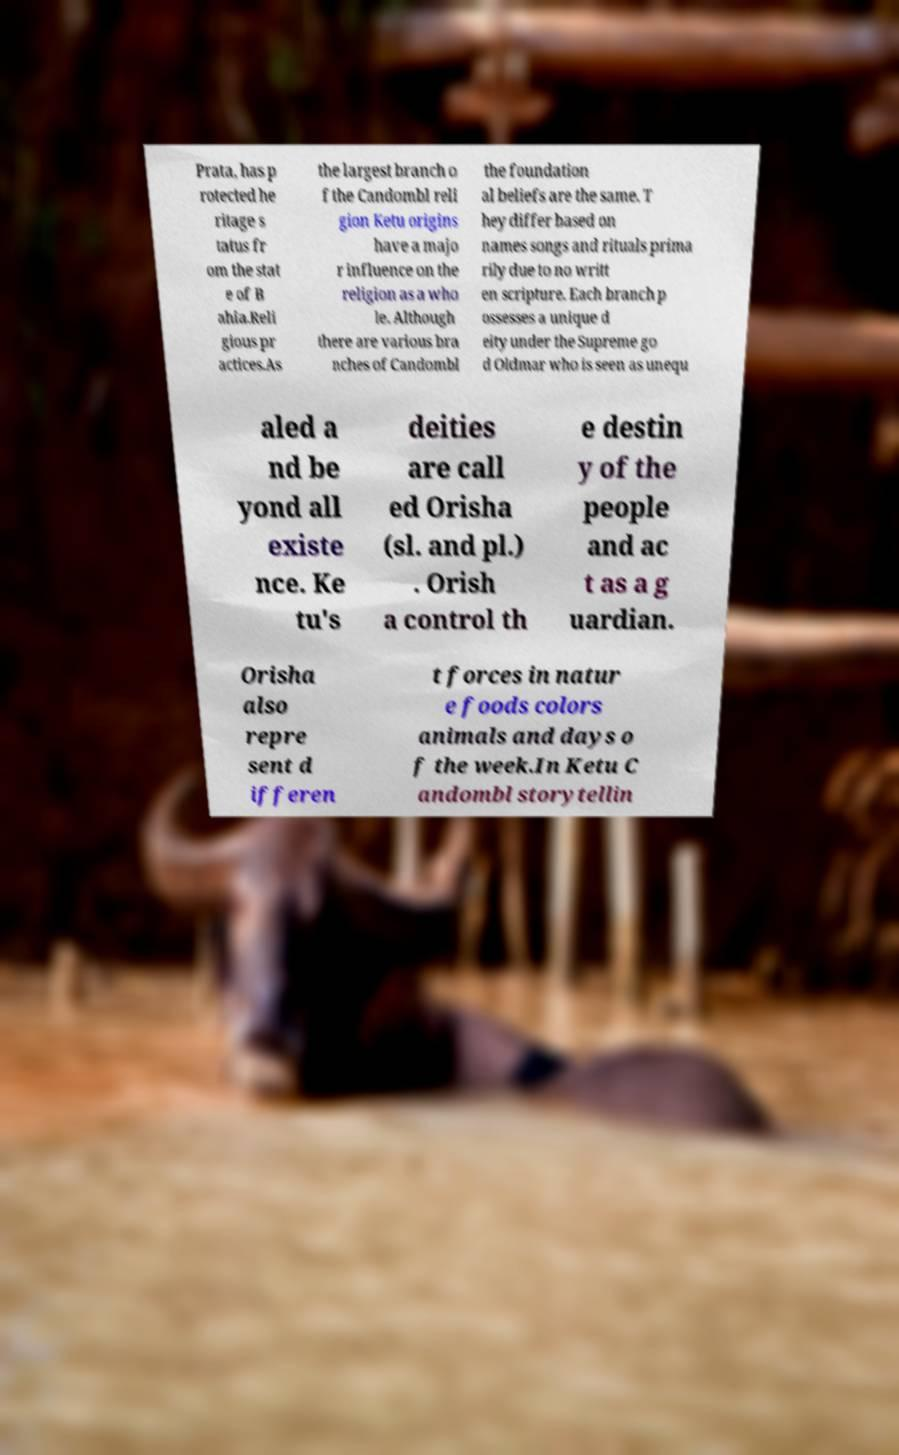Can you accurately transcribe the text from the provided image for me? Prata, has p rotected he ritage s tatus fr om the stat e of B ahia.Reli gious pr actices.As the largest branch o f the Candombl reli gion Ketu origins have a majo r influence on the religion as a who le. Although there are various bra nches of Candombl the foundation al beliefs are the same. T hey differ based on names songs and rituals prima rily due to no writt en scripture. Each branch p ossesses a unique d eity under the Supreme go d Oldmar who is seen as unequ aled a nd be yond all existe nce. Ke tu's deities are call ed Orisha (sl. and pl.) . Orish a control th e destin y of the people and ac t as a g uardian. Orisha also repre sent d ifferen t forces in natur e foods colors animals and days o f the week.In Ketu C andombl storytellin 